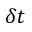Convert formula to latex. <formula><loc_0><loc_0><loc_500><loc_500>\delta { t }</formula> 